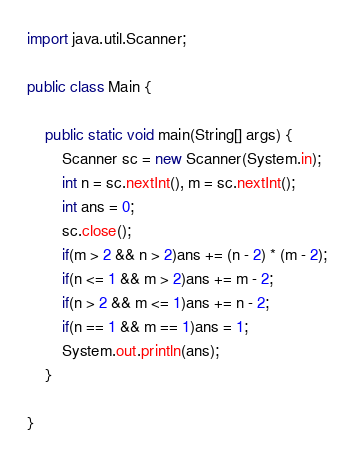Convert code to text. <code><loc_0><loc_0><loc_500><loc_500><_Java_>import java.util.Scanner;

public class Main {
	
	public static void main(String[] args) {
		Scanner sc = new Scanner(System.in);
		int n = sc.nextInt(), m = sc.nextInt();
		int ans = 0;
		sc.close();
		if(m > 2 && n > 2)ans += (n - 2) * (m - 2);
		if(n <= 1 && m > 2)ans += m - 2;
		if(n > 2 && m <= 1)ans += n - 2;
		if(n == 1 && m == 1)ans = 1;
		System.out.println(ans);
	}

}
</code> 